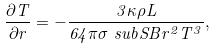Convert formula to latex. <formula><loc_0><loc_0><loc_500><loc_500>\frac { \partial T } { \partial r } = - \frac { 3 \kappa \rho L } { 6 4 \pi \sigma \ s u b { S B } r ^ { 2 } T ^ { 3 } } ,</formula> 